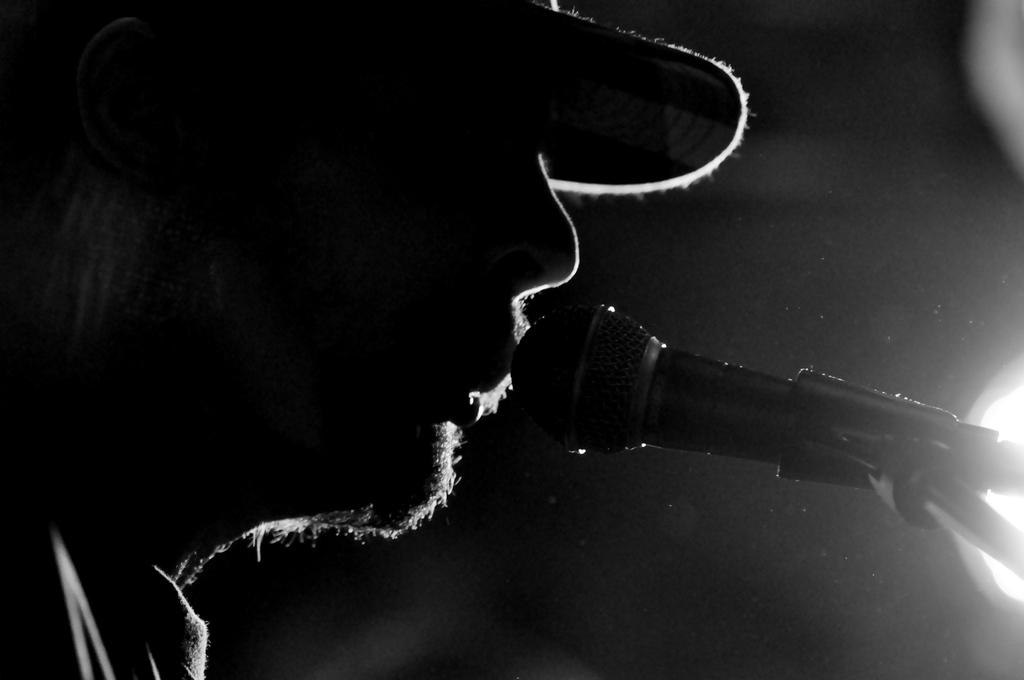What is the main subject of the image? There is a person in the image. What is the person wearing on their head? The person is wearing a cap. What object is in front of the person? There is a microphone with a stand in front of the person. How would you describe the background of the image? The background of the image has a dark view. Can you see a volleyball being played in the image? No, there is no volleyball or any indication of a game being played in the image. Is there a pot visible in the image? No, there is no pot present in the image. 